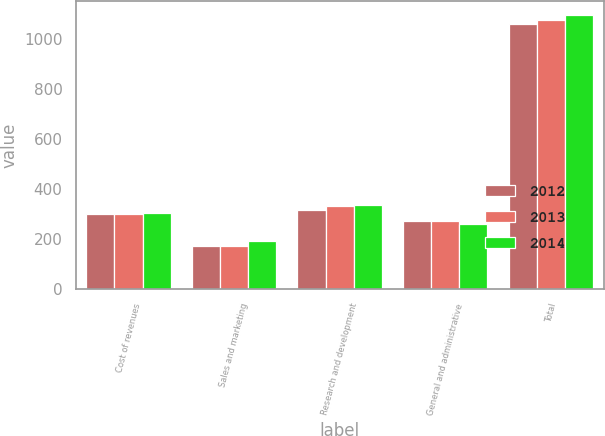<chart> <loc_0><loc_0><loc_500><loc_500><stacked_bar_chart><ecel><fcel>Cost of revenues<fcel>Sales and marketing<fcel>Research and development<fcel>General and administrative<fcel>Total<nl><fcel>2012<fcel>299<fcel>171<fcel>318<fcel>273<fcel>1061<nl><fcel>2013<fcel>301<fcel>172<fcel>333<fcel>273<fcel>1079<nl><fcel>2014<fcel>304<fcel>194<fcel>339<fcel>262<fcel>1099<nl></chart> 